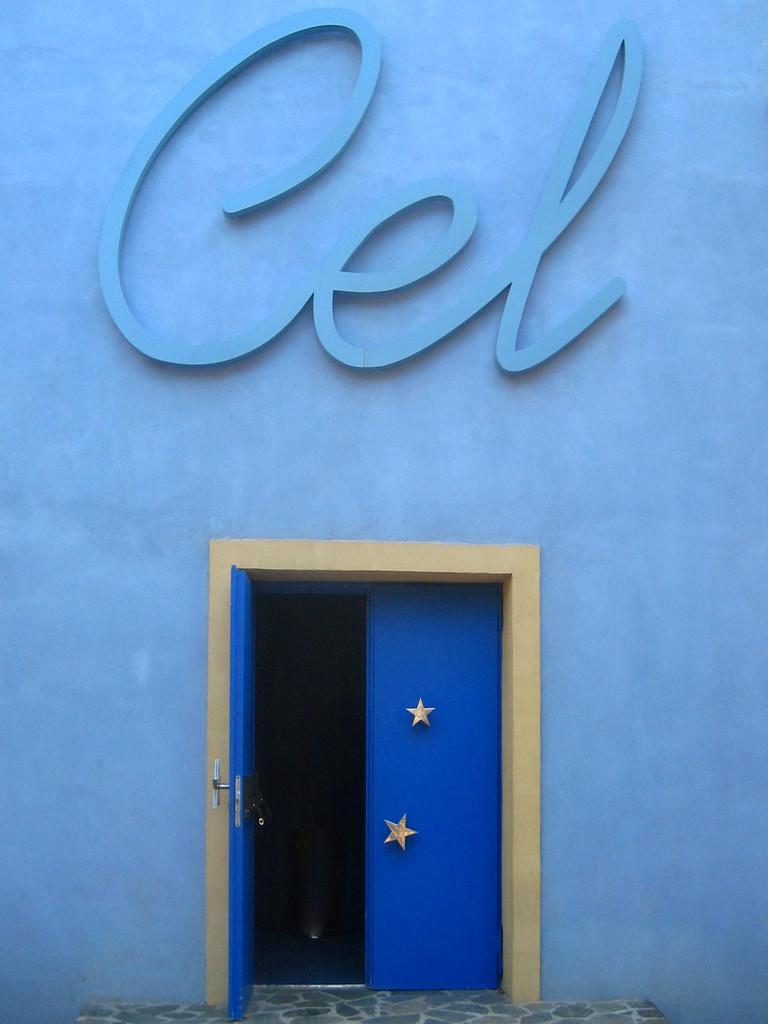Please provide a concise description of this image. In this picture we can see a blue color wall and doors, and we can find few stars on the door. 